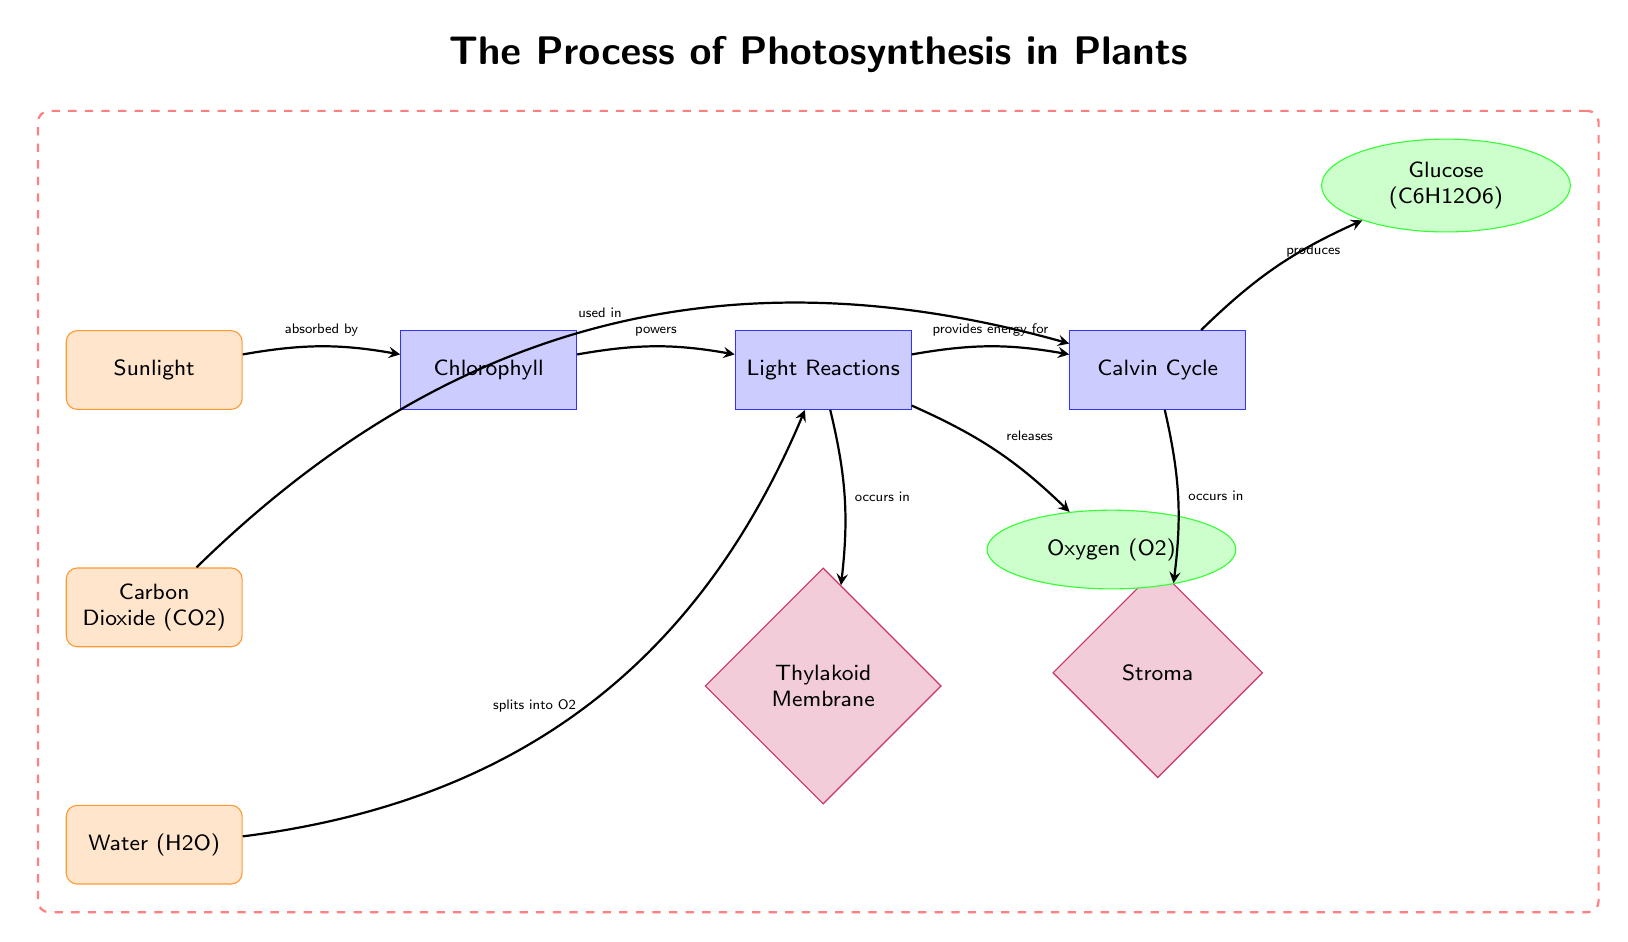What is absorbed by chlorophyll? The diagram indicates that sunlight is absorbed by chlorophyll, as represented by the arrow pointing from the "Sunlight" input node to the "Chlorophyll" process node.
Answer: Sunlight What process occurs in the thylakoid membrane? According to the diagram, the light reactions take place in the thylakoid membrane, as shown by the arrow leading from the "Light Reactions" process node to the "Thylakoid Membrane" location node.
Answer: Light Reactions How many outputs are there in the diagram? By examining the diagram, we can see there are two output nodes: "Glucose" and "Oxygen". Thus, the total count of outputs is 2.
Answer: 2 What splits into oxygen during the light reactions? The diagram illustrates that water (H2O) splits into oxygen (O2) during the light reactions, with a specific arrow pointing from the "Water" input node to the "Light Reactions" process node.
Answer: Water What provides energy for the Calvin cycle? The diagram indicates that the light reactions provide the necessary energy for the Calvin cycle. This is evident from the arrow pointing from the "Light Reactions" process node to the "Calvin Cycle" process node.
Answer: Light Reactions 